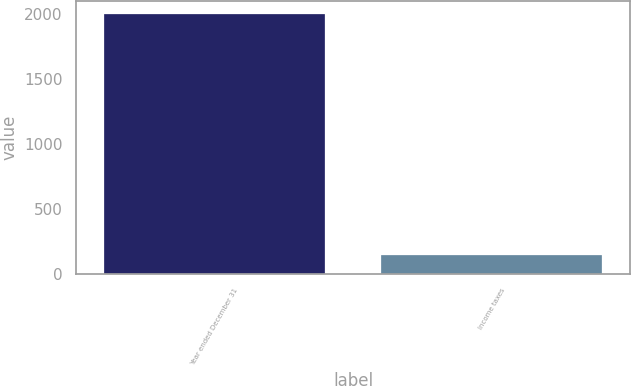<chart> <loc_0><loc_0><loc_500><loc_500><bar_chart><fcel>Year ended December 31<fcel>Income taxes<nl><fcel>2003<fcel>150<nl></chart> 